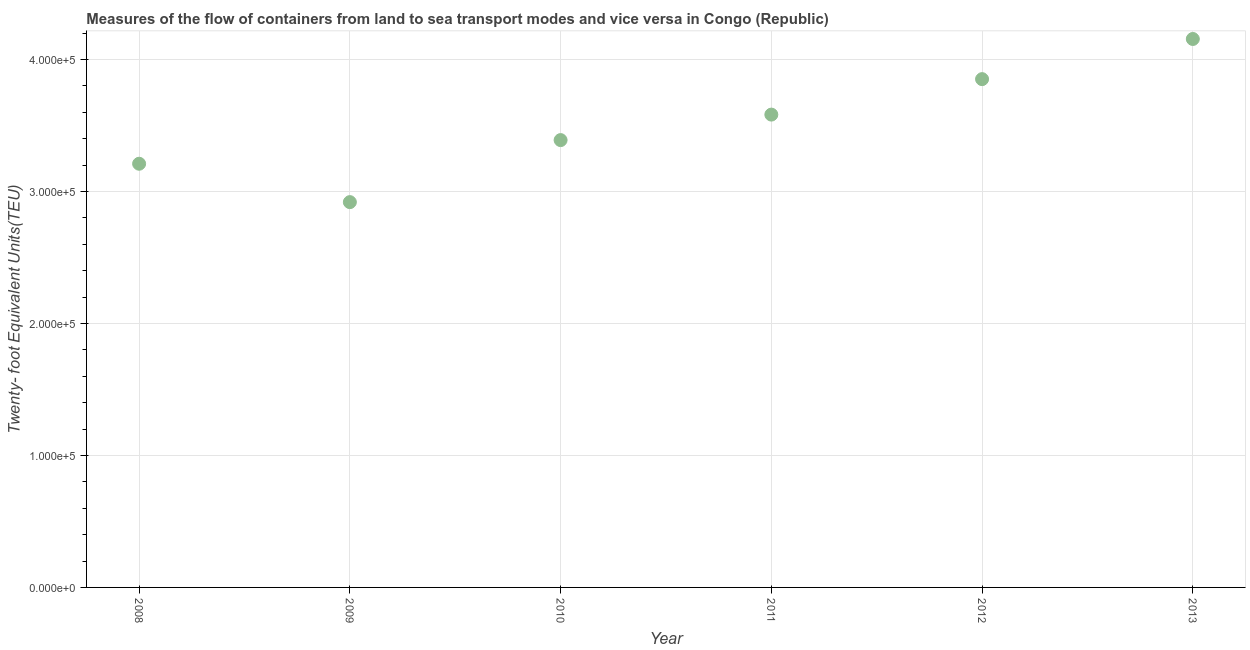What is the container port traffic in 2009?
Make the answer very short. 2.92e+05. Across all years, what is the maximum container port traffic?
Make the answer very short. 4.16e+05. Across all years, what is the minimum container port traffic?
Give a very brief answer. 2.92e+05. In which year was the container port traffic maximum?
Your answer should be very brief. 2013. What is the sum of the container port traffic?
Offer a terse response. 2.11e+06. What is the difference between the container port traffic in 2010 and 2012?
Make the answer very short. -4.62e+04. What is the average container port traffic per year?
Your response must be concise. 3.52e+05. What is the median container port traffic?
Provide a short and direct response. 3.49e+05. In how many years, is the container port traffic greater than 260000 TEU?
Provide a succinct answer. 6. What is the ratio of the container port traffic in 2009 to that in 2010?
Make the answer very short. 0.86. What is the difference between the highest and the second highest container port traffic?
Your response must be concise. 3.04e+04. Is the sum of the container port traffic in 2012 and 2013 greater than the maximum container port traffic across all years?
Keep it short and to the point. Yes. What is the difference between the highest and the lowest container port traffic?
Your answer should be compact. 1.24e+05. How many dotlines are there?
Keep it short and to the point. 1. How many years are there in the graph?
Your answer should be very brief. 6. Are the values on the major ticks of Y-axis written in scientific E-notation?
Provide a short and direct response. Yes. Does the graph contain any zero values?
Your answer should be compact. No. What is the title of the graph?
Make the answer very short. Measures of the flow of containers from land to sea transport modes and vice versa in Congo (Republic). What is the label or title of the Y-axis?
Provide a succinct answer. Twenty- foot Equivalent Units(TEU). What is the Twenty- foot Equivalent Units(TEU) in 2008?
Offer a very short reply. 3.21e+05. What is the Twenty- foot Equivalent Units(TEU) in 2009?
Offer a terse response. 2.92e+05. What is the Twenty- foot Equivalent Units(TEU) in 2010?
Make the answer very short. 3.39e+05. What is the Twenty- foot Equivalent Units(TEU) in 2011?
Keep it short and to the point. 3.58e+05. What is the Twenty- foot Equivalent Units(TEU) in 2012?
Your answer should be compact. 3.85e+05. What is the Twenty- foot Equivalent Units(TEU) in 2013?
Keep it short and to the point. 4.16e+05. What is the difference between the Twenty- foot Equivalent Units(TEU) in 2008 and 2009?
Provide a short and direct response. 2.91e+04. What is the difference between the Twenty- foot Equivalent Units(TEU) in 2008 and 2010?
Your answer should be very brief. -1.79e+04. What is the difference between the Twenty- foot Equivalent Units(TEU) in 2008 and 2011?
Keep it short and to the point. -3.72e+04. What is the difference between the Twenty- foot Equivalent Units(TEU) in 2008 and 2012?
Offer a terse response. -6.41e+04. What is the difference between the Twenty- foot Equivalent Units(TEU) in 2008 and 2013?
Ensure brevity in your answer.  -9.45e+04. What is the difference between the Twenty- foot Equivalent Units(TEU) in 2009 and 2010?
Provide a succinct answer. -4.70e+04. What is the difference between the Twenty- foot Equivalent Units(TEU) in 2009 and 2011?
Offer a very short reply. -6.63e+04. What is the difference between the Twenty- foot Equivalent Units(TEU) in 2009 and 2012?
Your answer should be very brief. -9.32e+04. What is the difference between the Twenty- foot Equivalent Units(TEU) in 2009 and 2013?
Your answer should be very brief. -1.24e+05. What is the difference between the Twenty- foot Equivalent Units(TEU) in 2010 and 2011?
Provide a succinct answer. -1.93e+04. What is the difference between the Twenty- foot Equivalent Units(TEU) in 2010 and 2012?
Make the answer very short. -4.62e+04. What is the difference between the Twenty- foot Equivalent Units(TEU) in 2010 and 2013?
Your answer should be very brief. -7.66e+04. What is the difference between the Twenty- foot Equivalent Units(TEU) in 2011 and 2012?
Your answer should be very brief. -2.69e+04. What is the difference between the Twenty- foot Equivalent Units(TEU) in 2011 and 2013?
Your answer should be compact. -5.73e+04. What is the difference between the Twenty- foot Equivalent Units(TEU) in 2012 and 2013?
Your response must be concise. -3.04e+04. What is the ratio of the Twenty- foot Equivalent Units(TEU) in 2008 to that in 2009?
Provide a succinct answer. 1.1. What is the ratio of the Twenty- foot Equivalent Units(TEU) in 2008 to that in 2010?
Offer a very short reply. 0.95. What is the ratio of the Twenty- foot Equivalent Units(TEU) in 2008 to that in 2011?
Keep it short and to the point. 0.9. What is the ratio of the Twenty- foot Equivalent Units(TEU) in 2008 to that in 2012?
Your answer should be very brief. 0.83. What is the ratio of the Twenty- foot Equivalent Units(TEU) in 2008 to that in 2013?
Give a very brief answer. 0.77. What is the ratio of the Twenty- foot Equivalent Units(TEU) in 2009 to that in 2010?
Offer a very short reply. 0.86. What is the ratio of the Twenty- foot Equivalent Units(TEU) in 2009 to that in 2011?
Provide a succinct answer. 0.81. What is the ratio of the Twenty- foot Equivalent Units(TEU) in 2009 to that in 2012?
Offer a very short reply. 0.76. What is the ratio of the Twenty- foot Equivalent Units(TEU) in 2009 to that in 2013?
Offer a very short reply. 0.7. What is the ratio of the Twenty- foot Equivalent Units(TEU) in 2010 to that in 2011?
Make the answer very short. 0.95. What is the ratio of the Twenty- foot Equivalent Units(TEU) in 2010 to that in 2013?
Keep it short and to the point. 0.82. What is the ratio of the Twenty- foot Equivalent Units(TEU) in 2011 to that in 2012?
Ensure brevity in your answer.  0.93. What is the ratio of the Twenty- foot Equivalent Units(TEU) in 2011 to that in 2013?
Ensure brevity in your answer.  0.86. What is the ratio of the Twenty- foot Equivalent Units(TEU) in 2012 to that in 2013?
Provide a succinct answer. 0.93. 